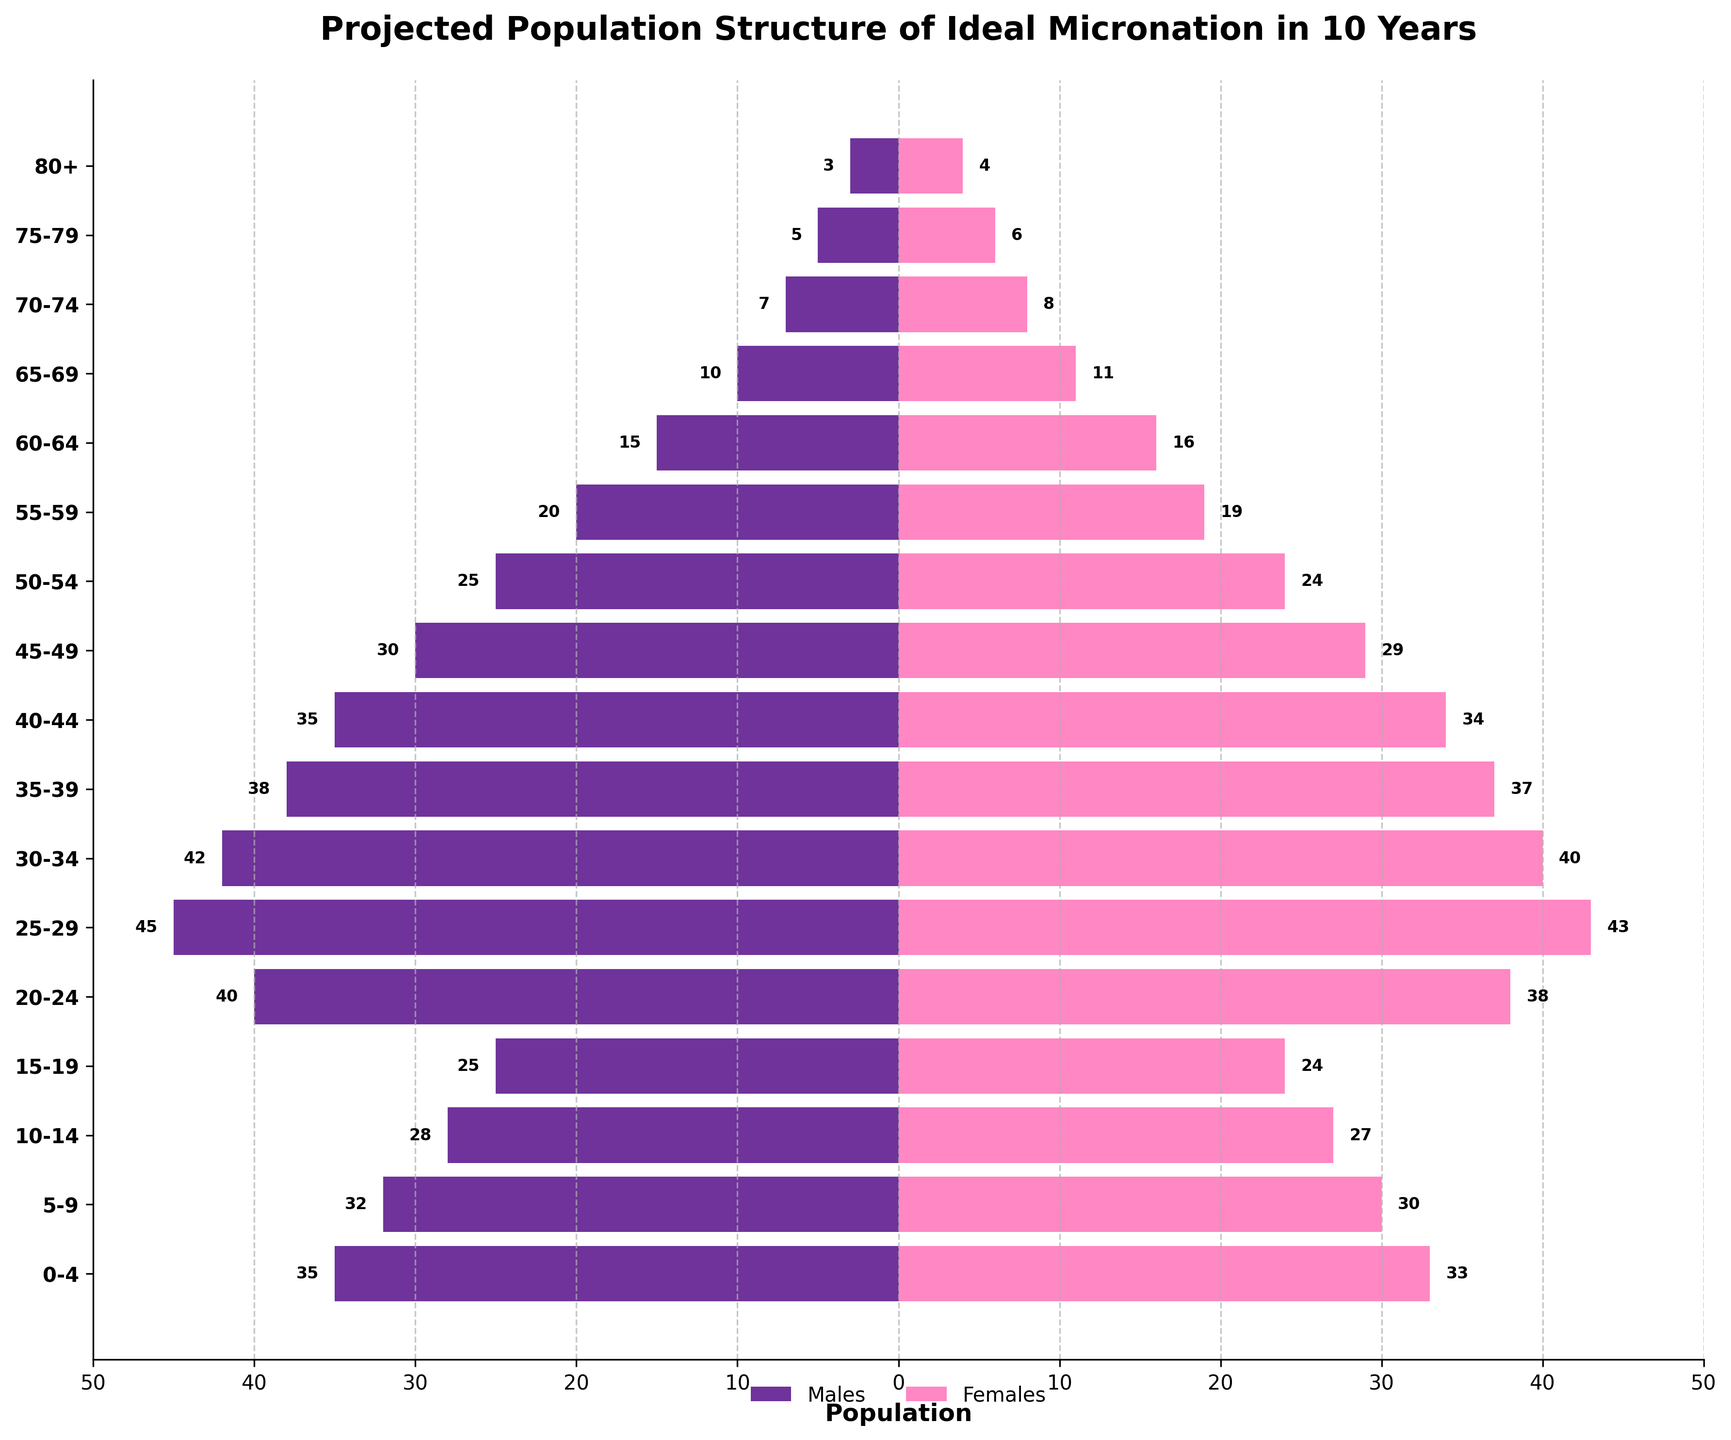What is the title of the figure? The title is found at the top of the figure and explicitly states what the figure is about.
Answer: Projected Population Structure of Ideal Micronation in 10 Years Which age group has the largest population of males? Look for the longest bar on the left side of the pyramid, which represents males, and identify its corresponding age group. The age groups are listed on the y-axis.
Answer: 25-29 Are there more males or females in the age group 60-64? Compare the lengths of the bars for males and females in the 60-64 age group. Males are on the left, and females are on the right.
Answer: Males What is the total population for the age group 10-14? Add the number of males and females for the 10-14 age group.
Answer: 55 (28 males + 27 females) Which gender has fewer individuals in the 80+ age group? Compare the lengths of the bars for males and females in the 80+ age group. Males are on the left, and females are on the right.
Answer: Males How does the population of males in the age group 0-4 compare to the population of males in the age group 70-74? Check the lengths of the bars representing males in the 0-4 and 70-74 age groups. Compare the two values.
Answer: More in 0-4 Which age group has a perfectly balanced gender population? Find the age group where the lengths of the bars for both males and females are equal.
Answer: 55-59 How many more females than males are there in the age group 65-69? Subtract the number of males from the number of females in the 65-69 age group.
Answer: 1 (11 females - 10 males) What proportion of the 25-29 age group is male? Divide the number of males by the total population in the 25-29 age group.
Answer: 0.5114 (45 males / (45 males + 43 females)) What is the average population per age group for females? Sum the female populations across all age groups and divide by the number of age groups.
Answer: 22.68 (sum of all female values / 17 age groups) 